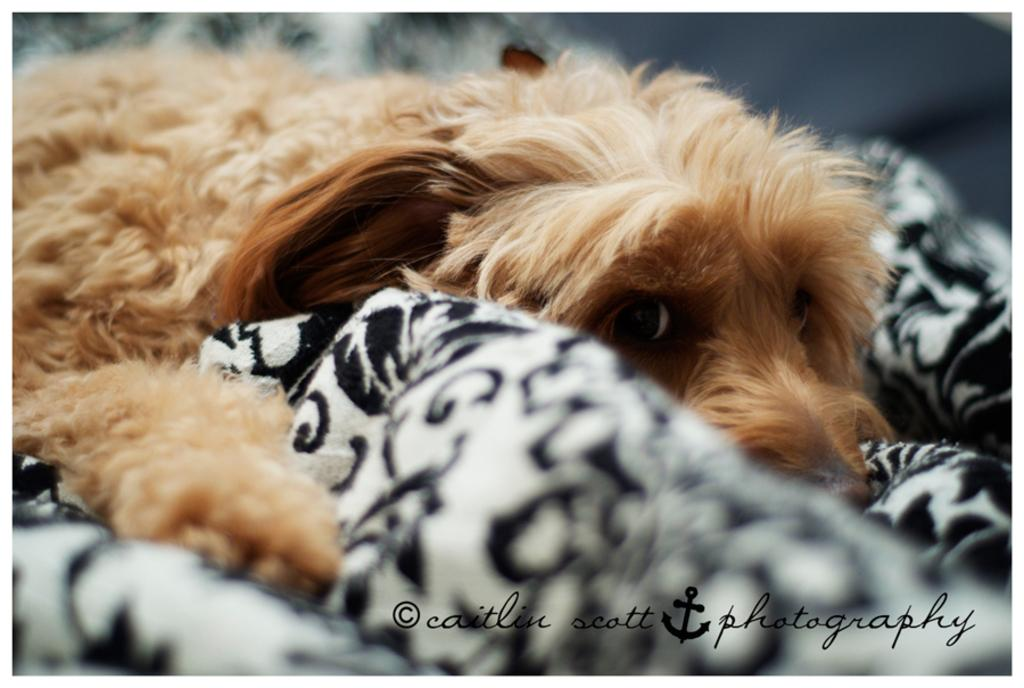What animal is present in the image? There is a dog in the image. What is the dog positioned on? The dog is on a cloth. Are there any ants crawling on the dog in the image? There is no mention of ants in the image, so it cannot be determined if they are present. 